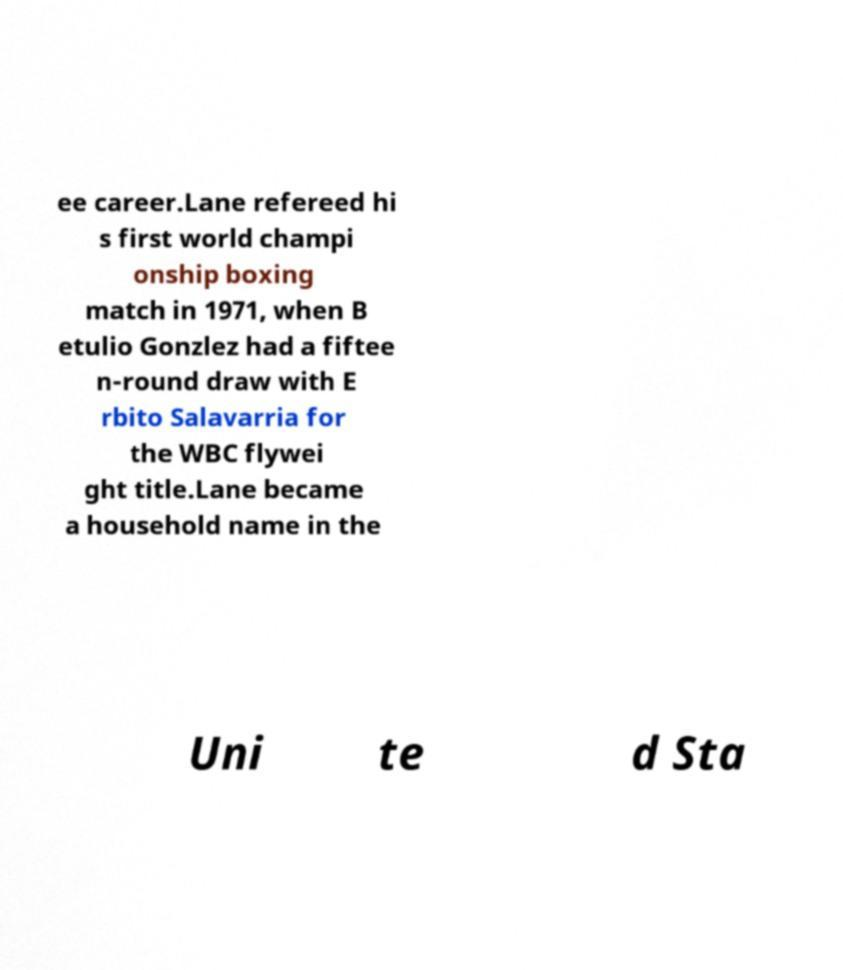Could you extract and type out the text from this image? ee career.Lane refereed hi s first world champi onship boxing match in 1971, when B etulio Gonzlez had a fiftee n-round draw with E rbito Salavarria for the WBC flywei ght title.Lane became a household name in the Uni te d Sta 